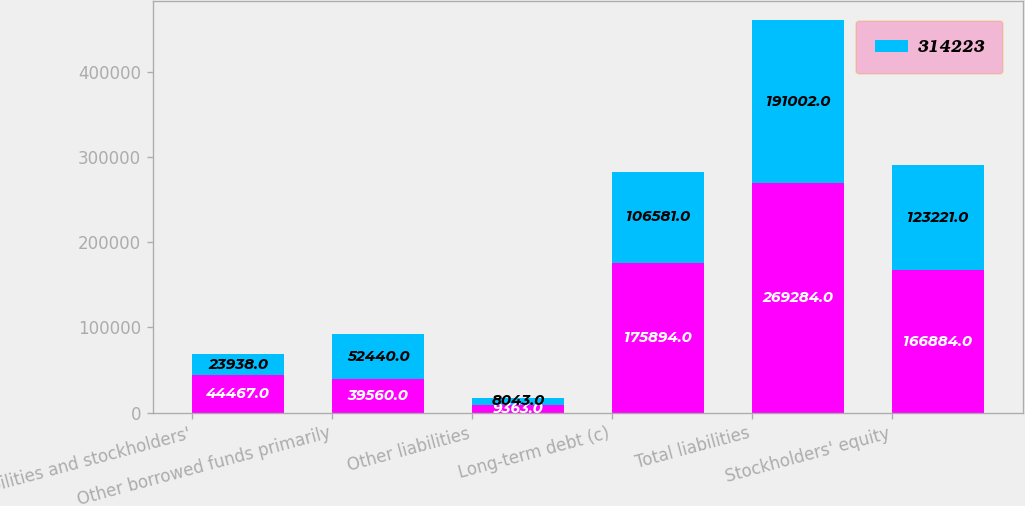Convert chart to OTSL. <chart><loc_0><loc_0><loc_500><loc_500><stacked_bar_chart><ecel><fcel>Liabilities and stockholders'<fcel>Other borrowed funds primarily<fcel>Other liabilities<fcel>Long-term debt (c)<fcel>Total liabilities<fcel>Stockholders' equity<nl><fcel>nan<fcel>44467<fcel>39560<fcel>9363<fcel>175894<fcel>269284<fcel>166884<nl><fcel>314223<fcel>23938<fcel>52440<fcel>8043<fcel>106581<fcel>191002<fcel>123221<nl></chart> 